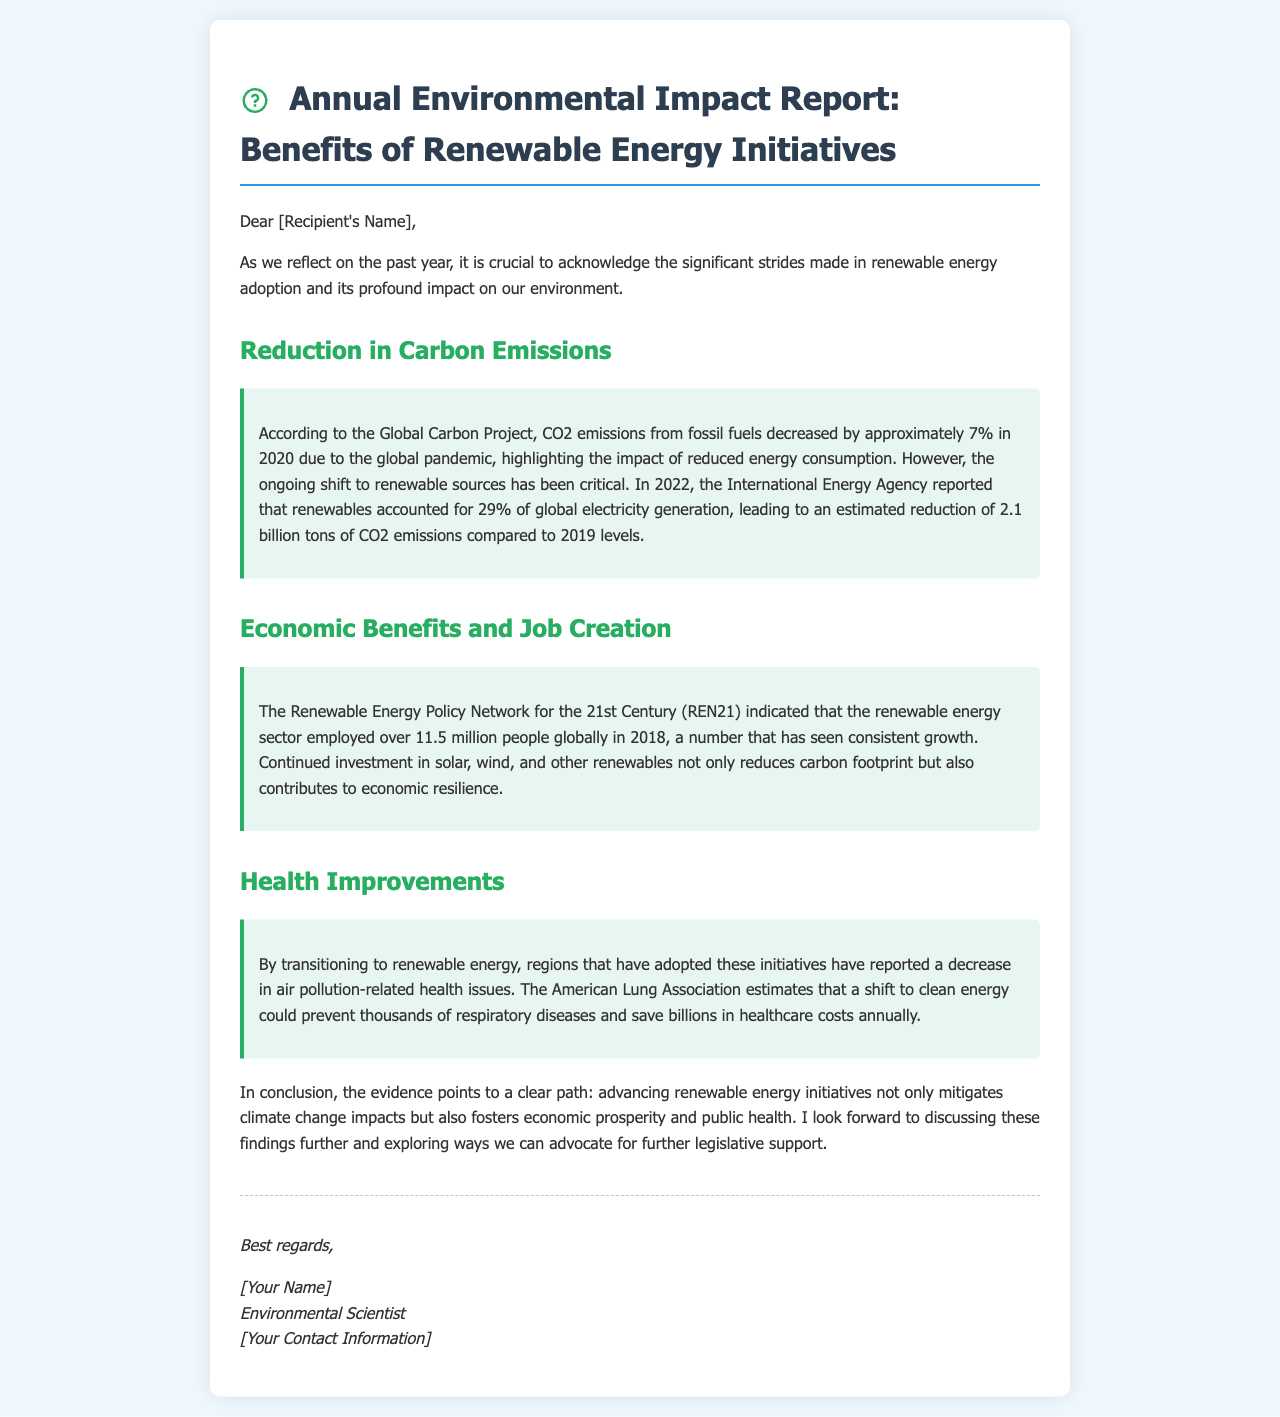What percentage of global electricity generation was from renewables in 2022? The document states that in 2022, renewables accounted for 29% of global electricity generation.
Answer: 29% How much did CO2 emissions decrease in 2020 due to the pandemic? The document mentions that CO2 emissions from fossil fuels decreased by approximately 7% in 2020 due to the global pandemic.
Answer: 7% What organization reported that the renewable energy sector employed over 11.5 million people globally? The Renewable Energy Policy Network for the 21st Century (REN21) is the organization that reported this figure.
Answer: REN21 How many tons of CO2 emissions were estimated to be reduced compared to 2019 levels in 2022? The document indicates an estimated reduction of 2.1 billion tons of CO2 emissions compared to 2019 levels.
Answer: 2.1 billion tons What health improvements can result from a shift to clean energy according to the American Lung Association? The document states that a shift to clean energy could prevent thousands of respiratory diseases and save billions in healthcare costs annually.
Answer: Respiratory diseases What type of initiatives are highlighted in the document for their environmental benefits? The document emphasizes renewable energy initiatives for their environmental benefits.
Answer: Renewable energy initiatives What is the concluding message of the report? The report concludes that advancing renewable energy initiatives mitigates climate change impacts and fosters economic prosperity and public health.
Answer: Mitigates climate change impacts Who is the author of the document? The author is identified as an Environmental Scientist in the signature section of the document.
Answer: Environmental Scientist 